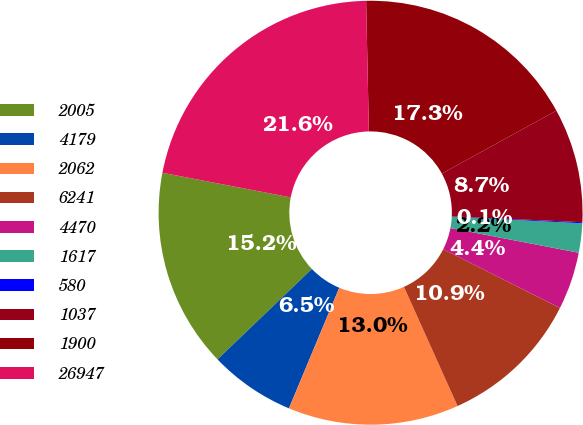Convert chart. <chart><loc_0><loc_0><loc_500><loc_500><pie_chart><fcel>2005<fcel>4179<fcel>2062<fcel>6241<fcel>4470<fcel>1617<fcel>580<fcel>1037<fcel>1900<fcel>26947<nl><fcel>15.18%<fcel>6.55%<fcel>13.02%<fcel>10.86%<fcel>4.39%<fcel>2.23%<fcel>0.08%<fcel>8.71%<fcel>17.34%<fcel>21.65%<nl></chart> 